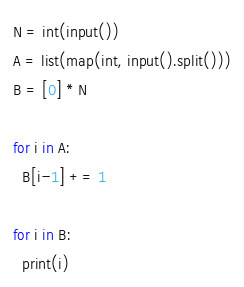<code> <loc_0><loc_0><loc_500><loc_500><_Python_>N = int(input())
A = list(map(int, input().split()))
B = [0] * N

for i in A:
  B[i-1] += 1

for i in B:
  print(i)</code> 